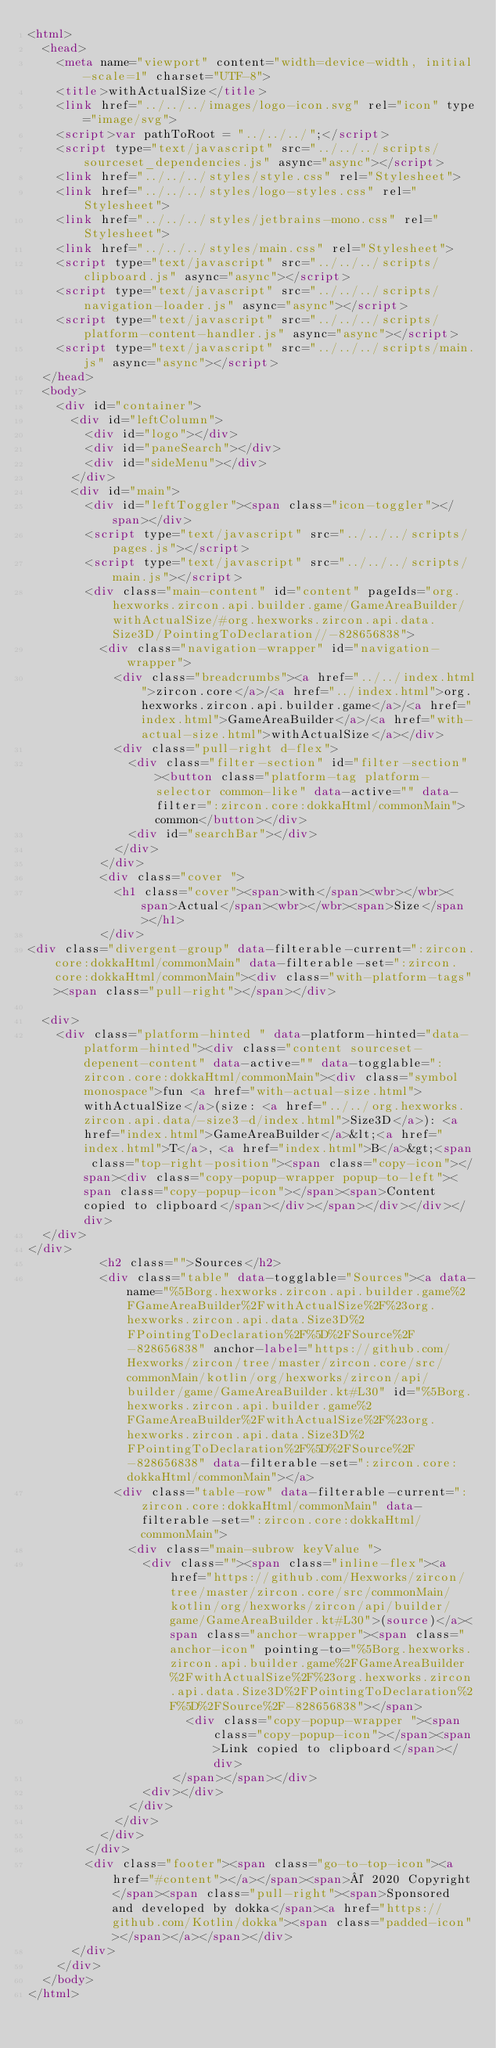Convert code to text. <code><loc_0><loc_0><loc_500><loc_500><_HTML_><html>
  <head>
    <meta name="viewport" content="width=device-width, initial-scale=1" charset="UTF-8">
    <title>withActualSize</title>
    <link href="../../../images/logo-icon.svg" rel="icon" type="image/svg">
    <script>var pathToRoot = "../../../";</script>
    <script type="text/javascript" src="../../../scripts/sourceset_dependencies.js" async="async"></script>
    <link href="../../../styles/style.css" rel="Stylesheet">
    <link href="../../../styles/logo-styles.css" rel="Stylesheet">
    <link href="../../../styles/jetbrains-mono.css" rel="Stylesheet">
    <link href="../../../styles/main.css" rel="Stylesheet">
    <script type="text/javascript" src="../../../scripts/clipboard.js" async="async"></script>
    <script type="text/javascript" src="../../../scripts/navigation-loader.js" async="async"></script>
    <script type="text/javascript" src="../../../scripts/platform-content-handler.js" async="async"></script>
    <script type="text/javascript" src="../../../scripts/main.js" async="async"></script>
  </head>
  <body>
    <div id="container">
      <div id="leftColumn">
        <div id="logo"></div>
        <div id="paneSearch"></div>
        <div id="sideMenu"></div>
      </div>
      <div id="main">
        <div id="leftToggler"><span class="icon-toggler"></span></div>
        <script type="text/javascript" src="../../../scripts/pages.js"></script>
        <script type="text/javascript" src="../../../scripts/main.js"></script>
        <div class="main-content" id="content" pageIds="org.hexworks.zircon.api.builder.game/GameAreaBuilder/withActualSize/#org.hexworks.zircon.api.data.Size3D/PointingToDeclaration//-828656838">
          <div class="navigation-wrapper" id="navigation-wrapper">
            <div class="breadcrumbs"><a href="../../index.html">zircon.core</a>/<a href="../index.html">org.hexworks.zircon.api.builder.game</a>/<a href="index.html">GameAreaBuilder</a>/<a href="with-actual-size.html">withActualSize</a></div>
            <div class="pull-right d-flex">
              <div class="filter-section" id="filter-section"><button class="platform-tag platform-selector common-like" data-active="" data-filter=":zircon.core:dokkaHtml/commonMain">common</button></div>
              <div id="searchBar"></div>
            </div>
          </div>
          <div class="cover ">
            <h1 class="cover"><span>with</span><wbr></wbr><span>Actual</span><wbr></wbr><span>Size</span></h1>
          </div>
<div class="divergent-group" data-filterable-current=":zircon.core:dokkaHtml/commonMain" data-filterable-set=":zircon.core:dokkaHtml/commonMain"><div class="with-platform-tags"><span class="pull-right"></span></div>

  <div>
    <div class="platform-hinted " data-platform-hinted="data-platform-hinted"><div class="content sourceset-depenent-content" data-active="" data-togglable=":zircon.core:dokkaHtml/commonMain"><div class="symbol monospace">fun <a href="with-actual-size.html">withActualSize</a>(size: <a href="../../org.hexworks.zircon.api.data/-size3-d/index.html">Size3D</a>): <a href="index.html">GameAreaBuilder</a>&lt;<a href="index.html">T</a>, <a href="index.html">B</a>&gt;<span class="top-right-position"><span class="copy-icon"></span><div class="copy-popup-wrapper popup-to-left"><span class="copy-popup-icon"></span><span>Content copied to clipboard</span></div></span></div></div></div>
  </div>
</div>
          <h2 class="">Sources</h2>
          <div class="table" data-togglable="Sources"><a data-name="%5Borg.hexworks.zircon.api.builder.game%2FGameAreaBuilder%2FwithActualSize%2F%23org.hexworks.zircon.api.data.Size3D%2FPointingToDeclaration%2F%5D%2FSource%2F-828656838" anchor-label="https://github.com/Hexworks/zircon/tree/master/zircon.core/src/commonMain/kotlin/org/hexworks/zircon/api/builder/game/GameAreaBuilder.kt#L30" id="%5Borg.hexworks.zircon.api.builder.game%2FGameAreaBuilder%2FwithActualSize%2F%23org.hexworks.zircon.api.data.Size3D%2FPointingToDeclaration%2F%5D%2FSource%2F-828656838" data-filterable-set=":zircon.core:dokkaHtml/commonMain"></a>
            <div class="table-row" data-filterable-current=":zircon.core:dokkaHtml/commonMain" data-filterable-set=":zircon.core:dokkaHtml/commonMain">
              <div class="main-subrow keyValue ">
                <div class=""><span class="inline-flex"><a href="https://github.com/Hexworks/zircon/tree/master/zircon.core/src/commonMain/kotlin/org/hexworks/zircon/api/builder/game/GameAreaBuilder.kt#L30">(source)</a><span class="anchor-wrapper"><span class="anchor-icon" pointing-to="%5Borg.hexworks.zircon.api.builder.game%2FGameAreaBuilder%2FwithActualSize%2F%23org.hexworks.zircon.api.data.Size3D%2FPointingToDeclaration%2F%5D%2FSource%2F-828656838"></span>
                      <div class="copy-popup-wrapper "><span class="copy-popup-icon"></span><span>Link copied to clipboard</span></div>
                    </span></span></div>
                <div></div>
              </div>
            </div>
          </div>
        </div>
        <div class="footer"><span class="go-to-top-icon"><a href="#content"></a></span><span>© 2020 Copyright</span><span class="pull-right"><span>Sponsored and developed by dokka</span><a href="https://github.com/Kotlin/dokka"><span class="padded-icon"></span></a></span></div>
      </div>
    </div>
  </body>
</html>

</code> 